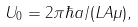Convert formula to latex. <formula><loc_0><loc_0><loc_500><loc_500>U _ { 0 } = 2 \pi \hbar { a } / ( L A \mu ) ,</formula> 